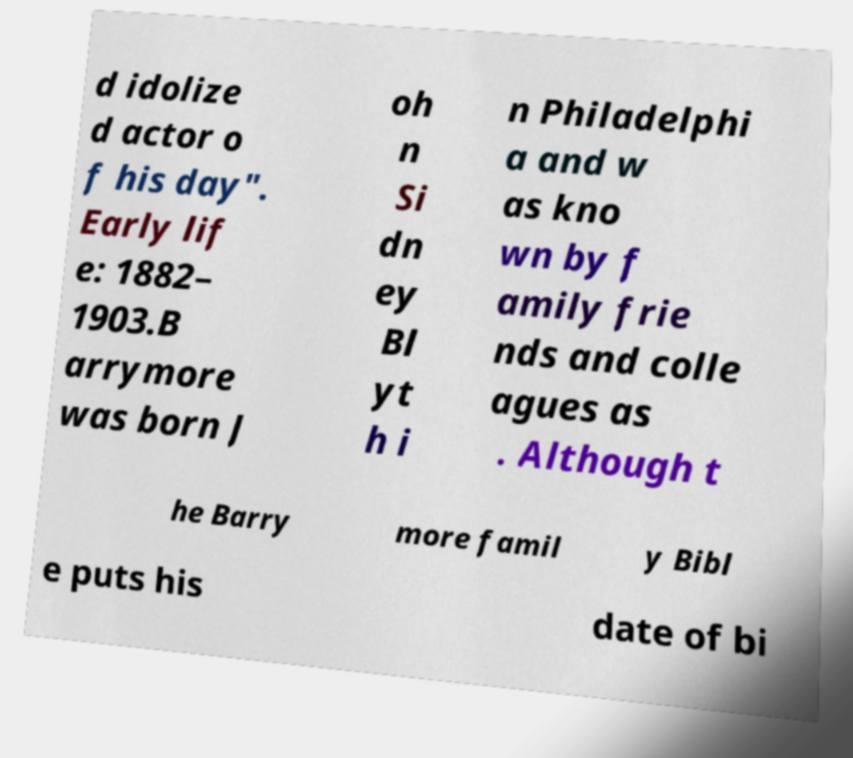Please identify and transcribe the text found in this image. d idolize d actor o f his day". Early lif e: 1882– 1903.B arrymore was born J oh n Si dn ey Bl yt h i n Philadelphi a and w as kno wn by f amily frie nds and colle agues as . Although t he Barry more famil y Bibl e puts his date of bi 